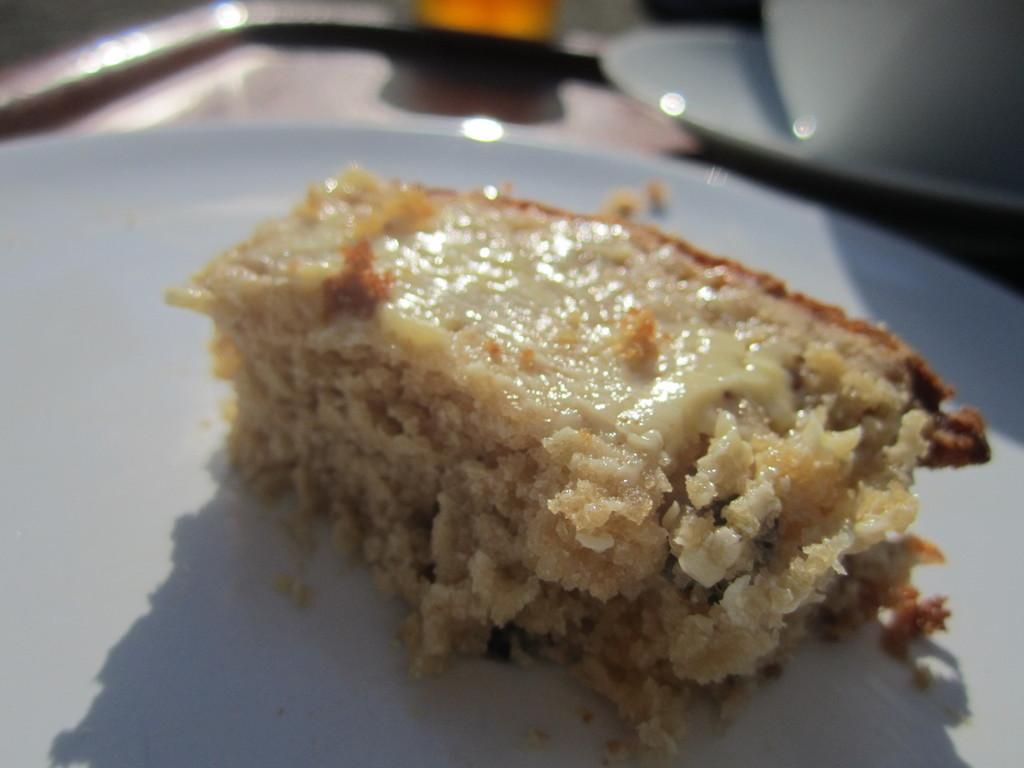What is the main subject of the image? The main subject of the image is a dessert on a serving plate. Can you describe the dessert in the image? Unfortunately, the specific type of dessert cannot be determined from the provided facts. What is the dessert placed on? The dessert is placed on a serving plate. What type of system is visible in the image? There is no system present in the image; it features a dessert on a serving plate. Which direction is the dessert facing in the image? The direction the dessert is facing cannot be determined from the provided facts. 